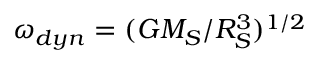Convert formula to latex. <formula><loc_0><loc_0><loc_500><loc_500>\omega _ { d y n } = ( G M _ { S } / R _ { S } ^ { 3 } ) ^ { 1 / 2 }</formula> 